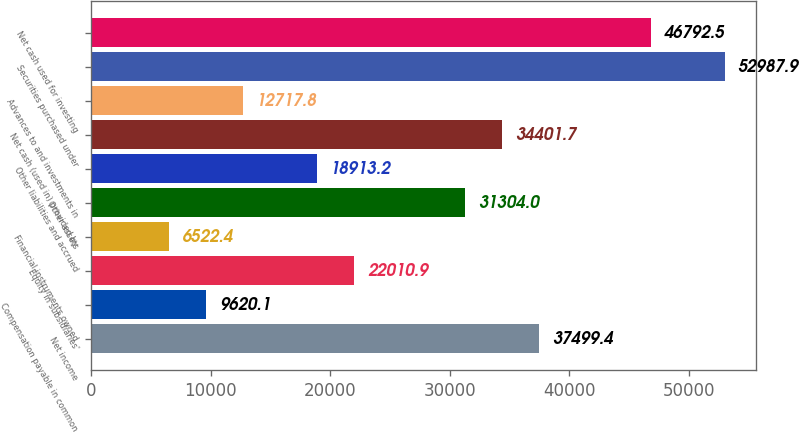Convert chart. <chart><loc_0><loc_0><loc_500><loc_500><bar_chart><fcel>Net income<fcel>Compensation payable in common<fcel>Equity in subsidiaries'<fcel>Financial instruments owned<fcel>Other assets<fcel>Other liabilities and accrued<fcel>Net cash (used in) provided by<fcel>Advances to and investments in<fcel>Securities purchased under<fcel>Net cash used for investing<nl><fcel>37499.4<fcel>9620.1<fcel>22010.9<fcel>6522.4<fcel>31304<fcel>18913.2<fcel>34401.7<fcel>12717.8<fcel>52987.9<fcel>46792.5<nl></chart> 